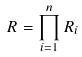Convert formula to latex. <formula><loc_0><loc_0><loc_500><loc_500>R = \prod _ { i = 1 } ^ { n } R _ { i }</formula> 